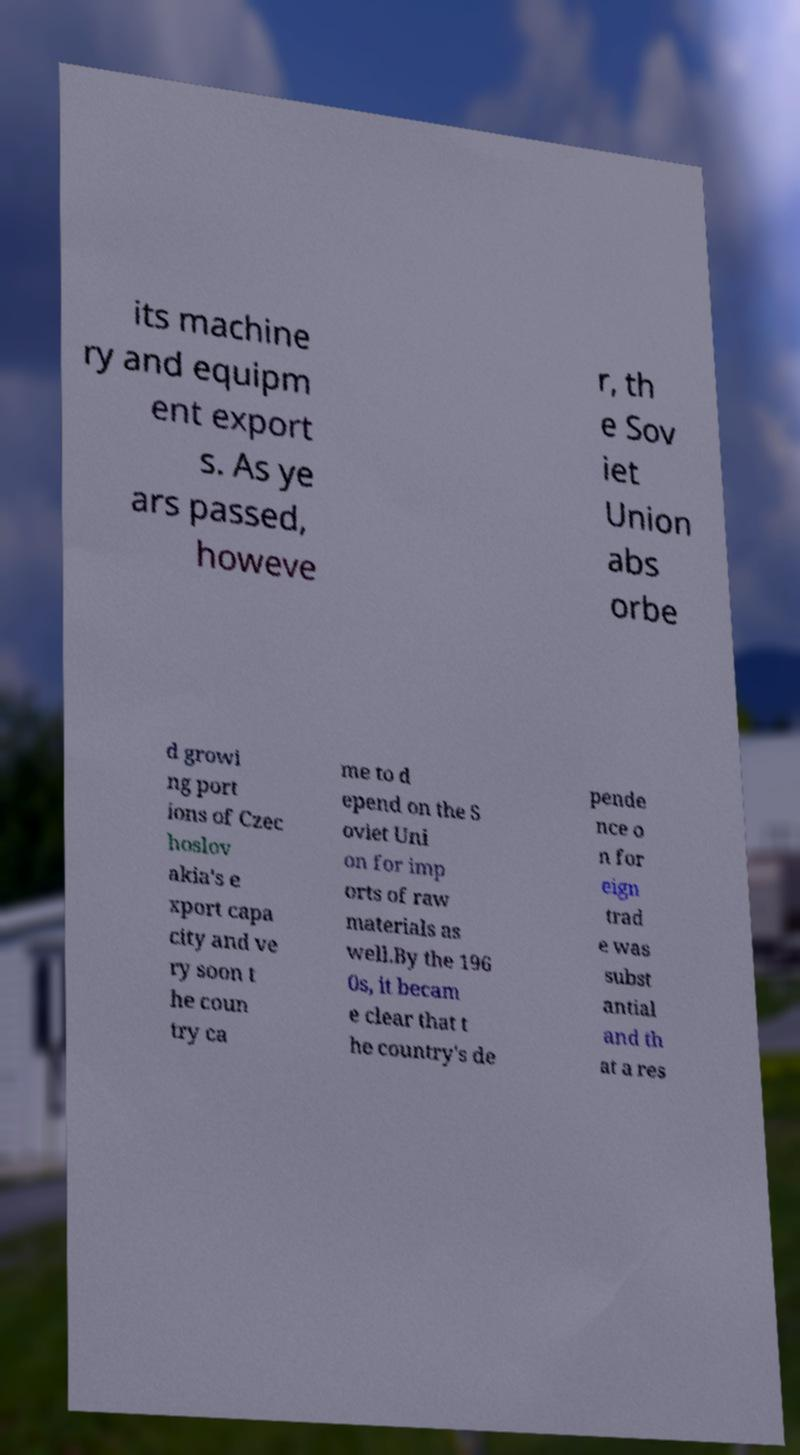Could you extract and type out the text from this image? its machine ry and equipm ent export s. As ye ars passed, howeve r, th e Sov iet Union abs orbe d growi ng port ions of Czec hoslov akia's e xport capa city and ve ry soon t he coun try ca me to d epend on the S oviet Uni on for imp orts of raw materials as well.By the 196 0s, it becam e clear that t he country's de pende nce o n for eign trad e was subst antial and th at a res 